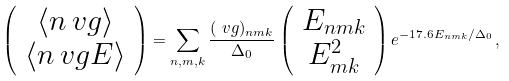Convert formula to latex. <formula><loc_0><loc_0><loc_500><loc_500>\left ( \begin{array} { c } \langle n \ v g \rangle \\ \langle n \ v g E \rangle \end{array} \right ) = \sum _ { n , m , k } \frac { ( \ v g ) _ { n m k } } { \Delta _ { 0 } } \left ( \begin{array} { c } E _ { n m k } \\ E _ { m k } ^ { 2 } \end{array} \right ) e ^ { - 1 7 . 6 E _ { n m k } / \Delta _ { 0 } } \, ,</formula> 